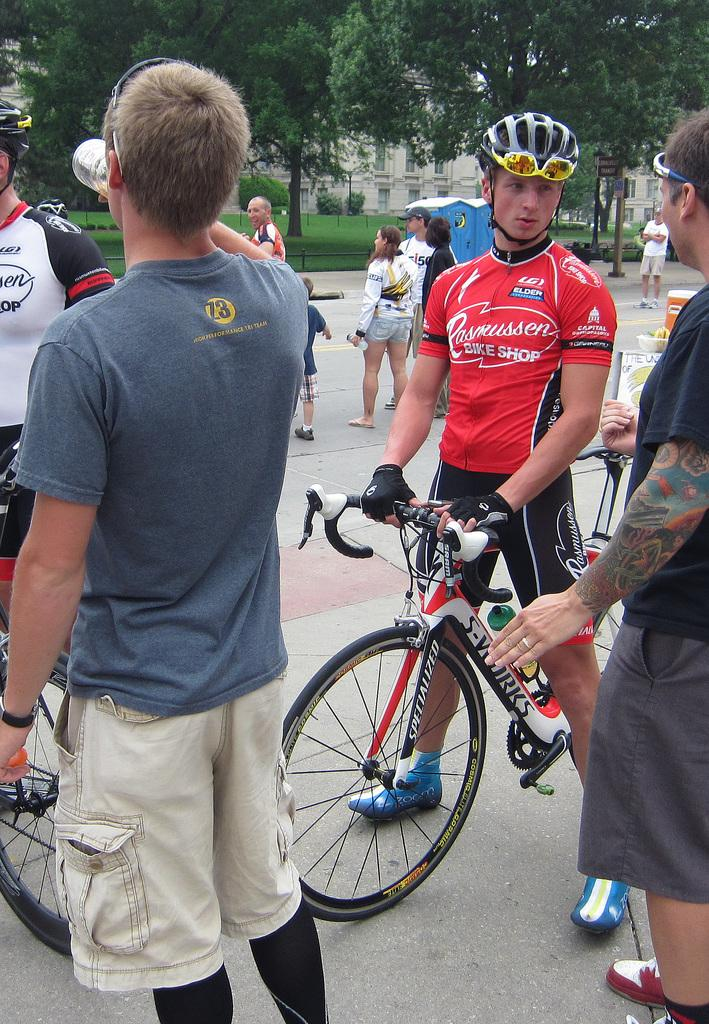How many people are in the image? There is a group of people in the image. Where are the people located in the image? The people are standing on the road. What other object can be seen in the image besides the people? There is a bicycle in the image. What can be seen in the background of the image? There are trees and buildings in the background of the image. What flavor of ice cream is being discussed by the people in the image? There is no mention of ice cream or any discussion in the image. 